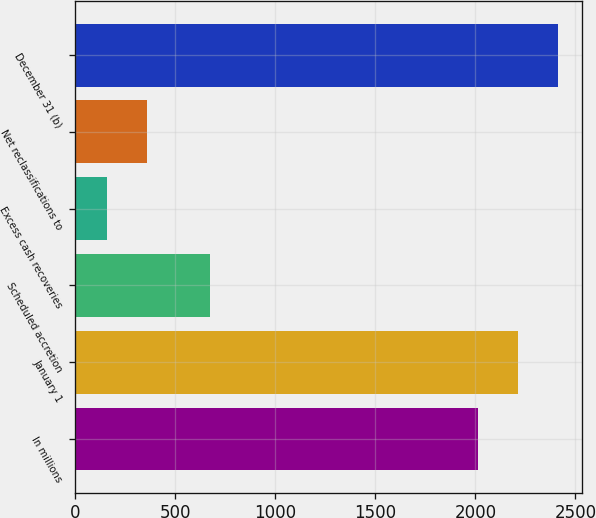<chart> <loc_0><loc_0><loc_500><loc_500><bar_chart><fcel>In millions<fcel>January 1<fcel>Scheduled accretion<fcel>Excess cash recoveries<fcel>Net reclassifications to<fcel>December 31 (b)<nl><fcel>2012<fcel>2212.9<fcel>671<fcel>157<fcel>357.9<fcel>2413.8<nl></chart> 